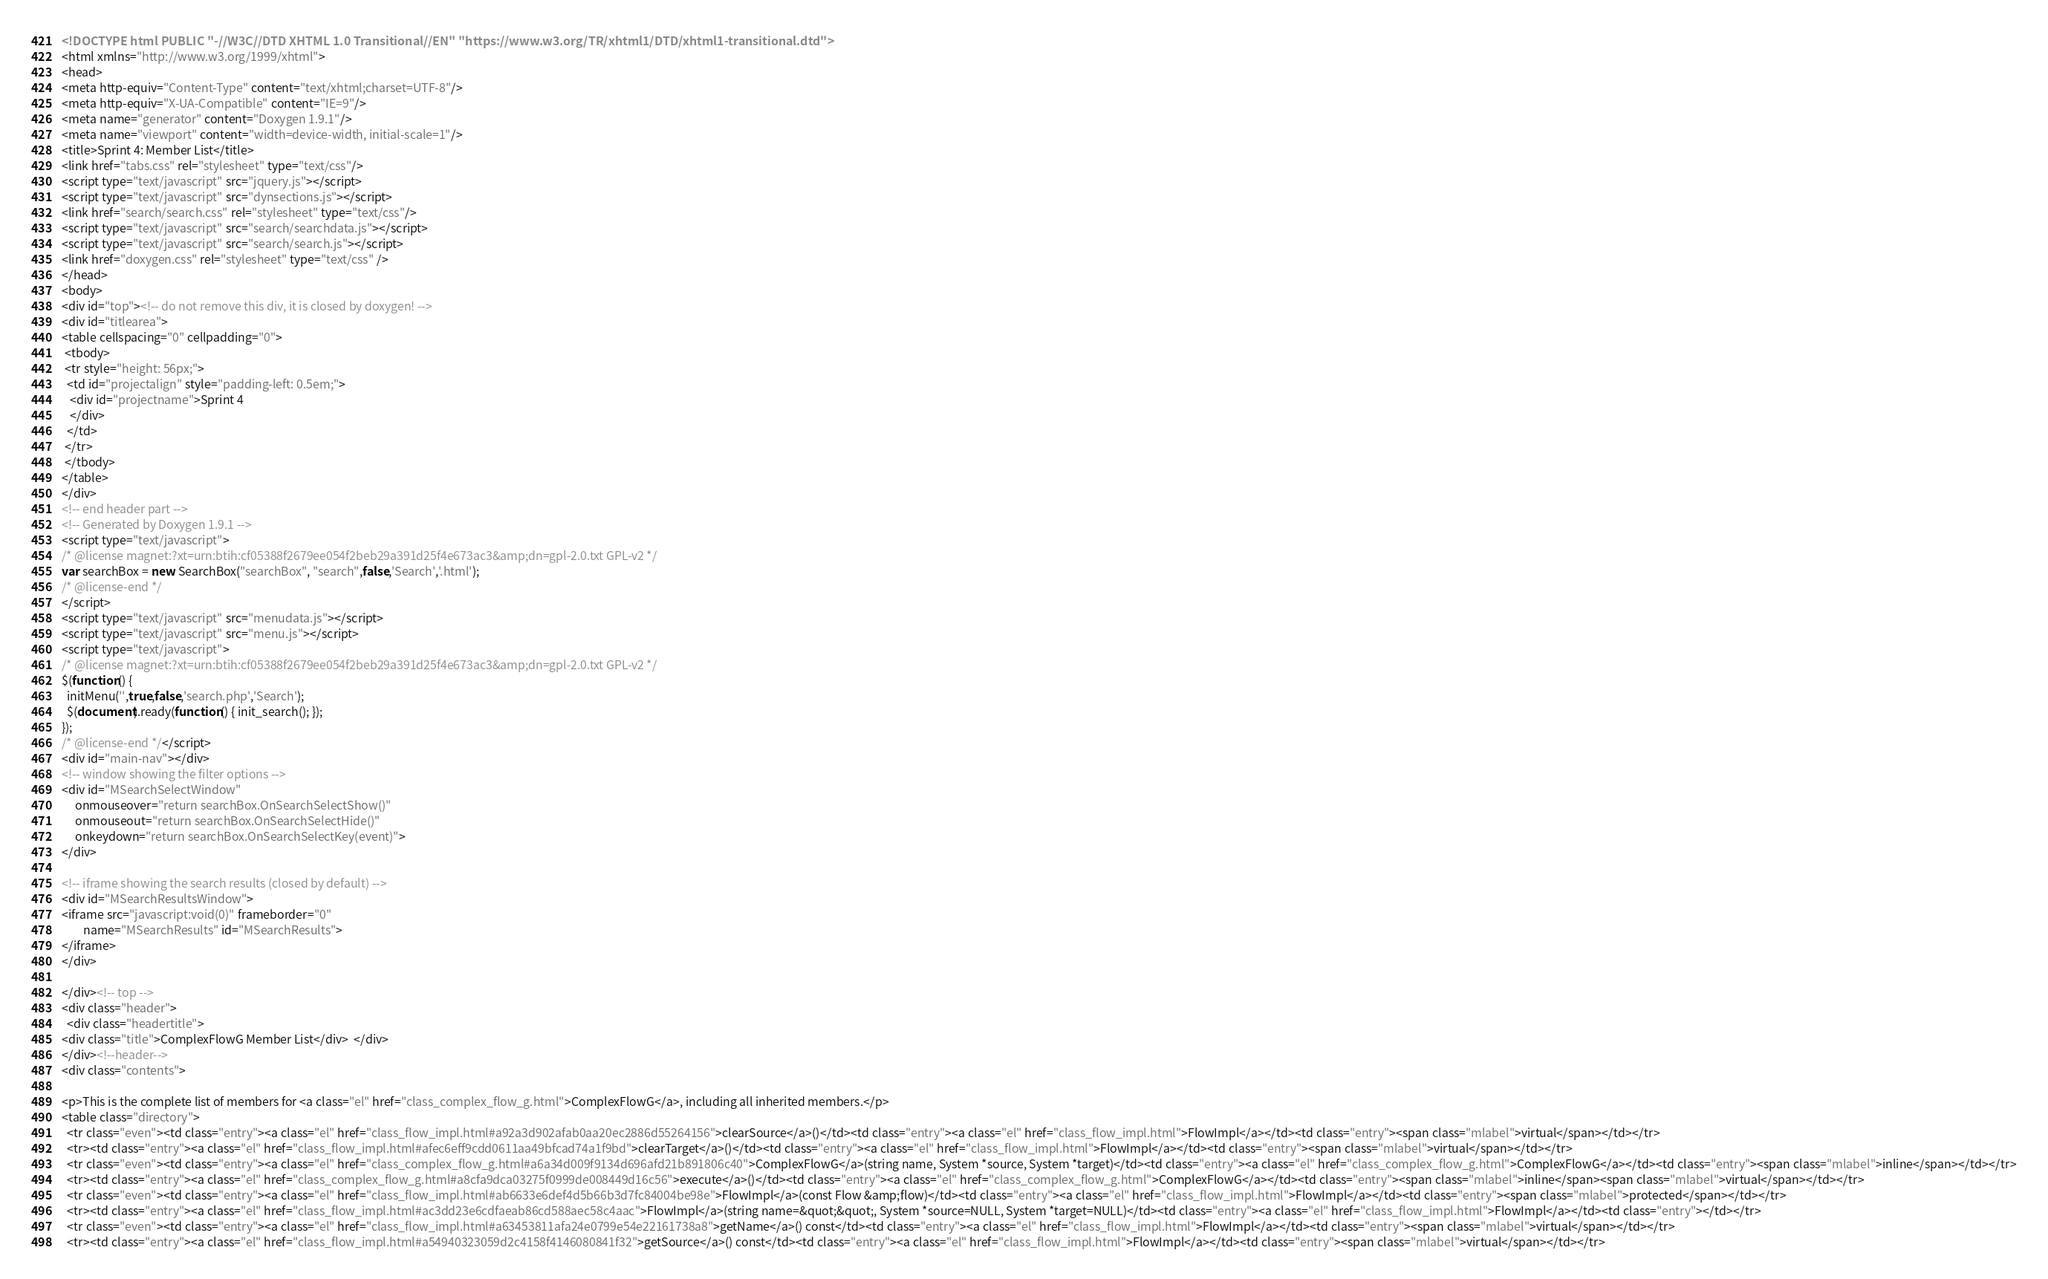Convert code to text. <code><loc_0><loc_0><loc_500><loc_500><_HTML_><!DOCTYPE html PUBLIC "-//W3C//DTD XHTML 1.0 Transitional//EN" "https://www.w3.org/TR/xhtml1/DTD/xhtml1-transitional.dtd">
<html xmlns="http://www.w3.org/1999/xhtml">
<head>
<meta http-equiv="Content-Type" content="text/xhtml;charset=UTF-8"/>
<meta http-equiv="X-UA-Compatible" content="IE=9"/>
<meta name="generator" content="Doxygen 1.9.1"/>
<meta name="viewport" content="width=device-width, initial-scale=1"/>
<title>Sprint 4: Member List</title>
<link href="tabs.css" rel="stylesheet" type="text/css"/>
<script type="text/javascript" src="jquery.js"></script>
<script type="text/javascript" src="dynsections.js"></script>
<link href="search/search.css" rel="stylesheet" type="text/css"/>
<script type="text/javascript" src="search/searchdata.js"></script>
<script type="text/javascript" src="search/search.js"></script>
<link href="doxygen.css" rel="stylesheet" type="text/css" />
</head>
<body>
<div id="top"><!-- do not remove this div, it is closed by doxygen! -->
<div id="titlearea">
<table cellspacing="0" cellpadding="0">
 <tbody>
 <tr style="height: 56px;">
  <td id="projectalign" style="padding-left: 0.5em;">
   <div id="projectname">Sprint 4
   </div>
  </td>
 </tr>
 </tbody>
</table>
</div>
<!-- end header part -->
<!-- Generated by Doxygen 1.9.1 -->
<script type="text/javascript">
/* @license magnet:?xt=urn:btih:cf05388f2679ee054f2beb29a391d25f4e673ac3&amp;dn=gpl-2.0.txt GPL-v2 */
var searchBox = new SearchBox("searchBox", "search",false,'Search','.html');
/* @license-end */
</script>
<script type="text/javascript" src="menudata.js"></script>
<script type="text/javascript" src="menu.js"></script>
<script type="text/javascript">
/* @license magnet:?xt=urn:btih:cf05388f2679ee054f2beb29a391d25f4e673ac3&amp;dn=gpl-2.0.txt GPL-v2 */
$(function() {
  initMenu('',true,false,'search.php','Search');
  $(document).ready(function() { init_search(); });
});
/* @license-end */</script>
<div id="main-nav"></div>
<!-- window showing the filter options -->
<div id="MSearchSelectWindow"
     onmouseover="return searchBox.OnSearchSelectShow()"
     onmouseout="return searchBox.OnSearchSelectHide()"
     onkeydown="return searchBox.OnSearchSelectKey(event)">
</div>

<!-- iframe showing the search results (closed by default) -->
<div id="MSearchResultsWindow">
<iframe src="javascript:void(0)" frameborder="0" 
        name="MSearchResults" id="MSearchResults">
</iframe>
</div>

</div><!-- top -->
<div class="header">
  <div class="headertitle">
<div class="title">ComplexFlowG Member List</div>  </div>
</div><!--header-->
<div class="contents">

<p>This is the complete list of members for <a class="el" href="class_complex_flow_g.html">ComplexFlowG</a>, including all inherited members.</p>
<table class="directory">
  <tr class="even"><td class="entry"><a class="el" href="class_flow_impl.html#a92a3d902afab0aa20ec2886d55264156">clearSource</a>()</td><td class="entry"><a class="el" href="class_flow_impl.html">FlowImpl</a></td><td class="entry"><span class="mlabel">virtual</span></td></tr>
  <tr><td class="entry"><a class="el" href="class_flow_impl.html#afec6eff9cdd0611aa49bfcad74a1f9bd">clearTarget</a>()</td><td class="entry"><a class="el" href="class_flow_impl.html">FlowImpl</a></td><td class="entry"><span class="mlabel">virtual</span></td></tr>
  <tr class="even"><td class="entry"><a class="el" href="class_complex_flow_g.html#a6a34d009f9134d696afd21b891806c40">ComplexFlowG</a>(string name, System *source, System *target)</td><td class="entry"><a class="el" href="class_complex_flow_g.html">ComplexFlowG</a></td><td class="entry"><span class="mlabel">inline</span></td></tr>
  <tr><td class="entry"><a class="el" href="class_complex_flow_g.html#a8cfa9dca03275f0999de008449d16c56">execute</a>()</td><td class="entry"><a class="el" href="class_complex_flow_g.html">ComplexFlowG</a></td><td class="entry"><span class="mlabel">inline</span><span class="mlabel">virtual</span></td></tr>
  <tr class="even"><td class="entry"><a class="el" href="class_flow_impl.html#ab6633e6def4d5b66b3d7fc84004be98e">FlowImpl</a>(const Flow &amp;flow)</td><td class="entry"><a class="el" href="class_flow_impl.html">FlowImpl</a></td><td class="entry"><span class="mlabel">protected</span></td></tr>
  <tr><td class="entry"><a class="el" href="class_flow_impl.html#ac3dd23e6cdfaeab86cd588aec58c4aac">FlowImpl</a>(string name=&quot;&quot;, System *source=NULL, System *target=NULL)</td><td class="entry"><a class="el" href="class_flow_impl.html">FlowImpl</a></td><td class="entry"></td></tr>
  <tr class="even"><td class="entry"><a class="el" href="class_flow_impl.html#a63453811afa24e0799e54e22161738a8">getName</a>() const</td><td class="entry"><a class="el" href="class_flow_impl.html">FlowImpl</a></td><td class="entry"><span class="mlabel">virtual</span></td></tr>
  <tr><td class="entry"><a class="el" href="class_flow_impl.html#a54940323059d2c4158f4146080841f32">getSource</a>() const</td><td class="entry"><a class="el" href="class_flow_impl.html">FlowImpl</a></td><td class="entry"><span class="mlabel">virtual</span></td></tr></code> 